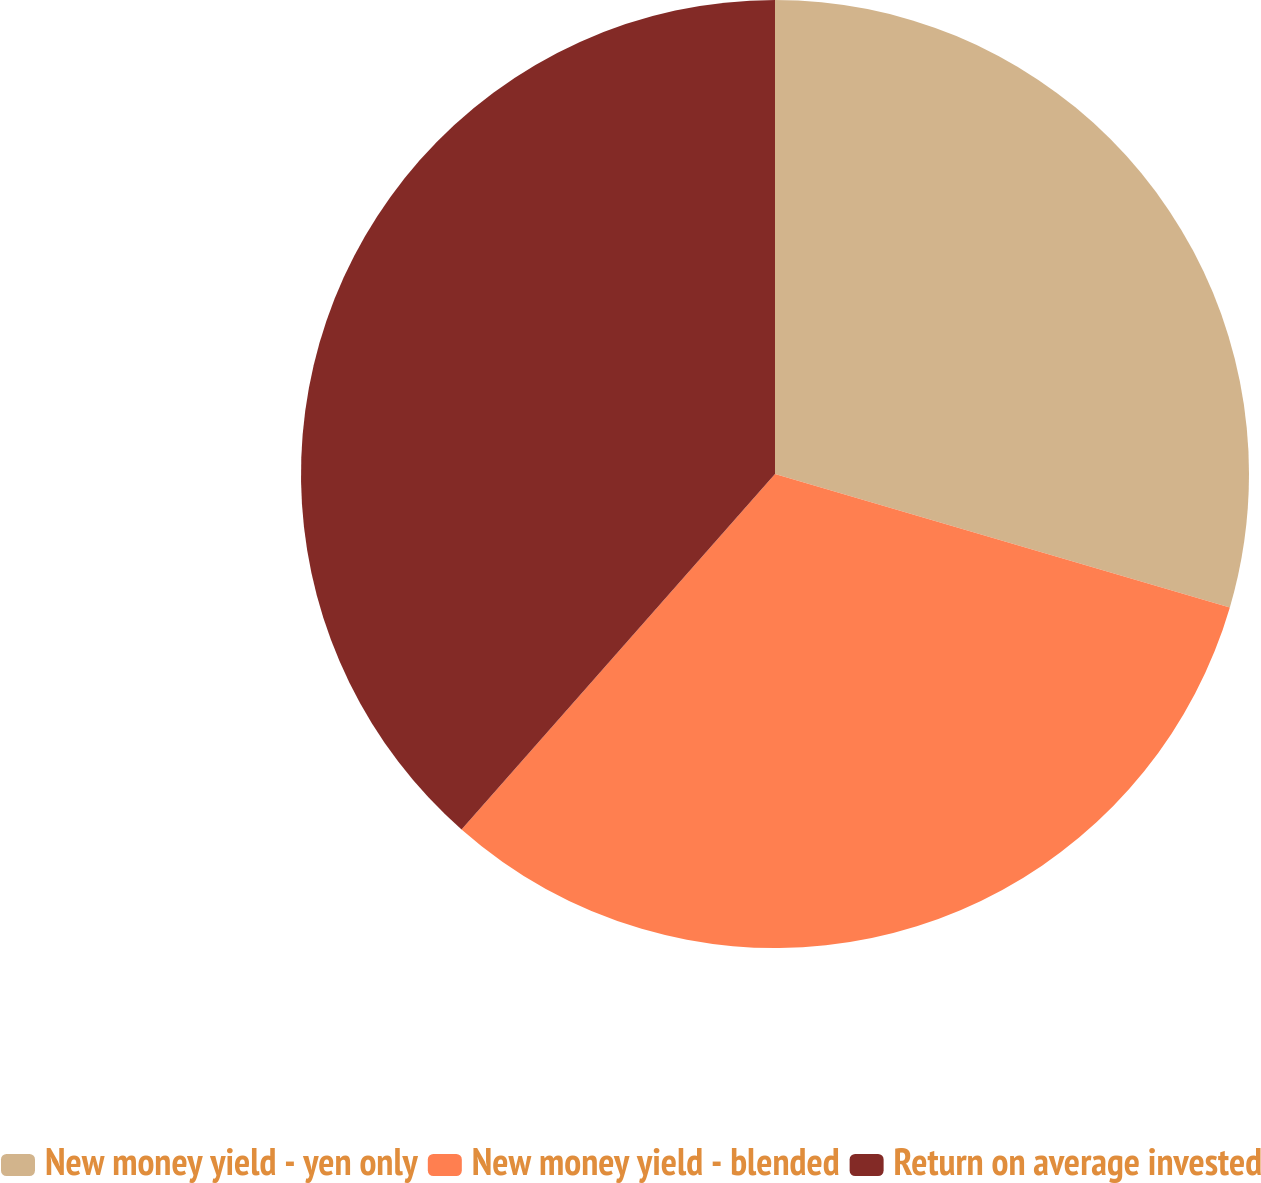Convert chart. <chart><loc_0><loc_0><loc_500><loc_500><pie_chart><fcel>New money yield - yen only<fcel>New money yield - blended<fcel>Return on average invested<nl><fcel>29.54%<fcel>31.96%<fcel>38.5%<nl></chart> 